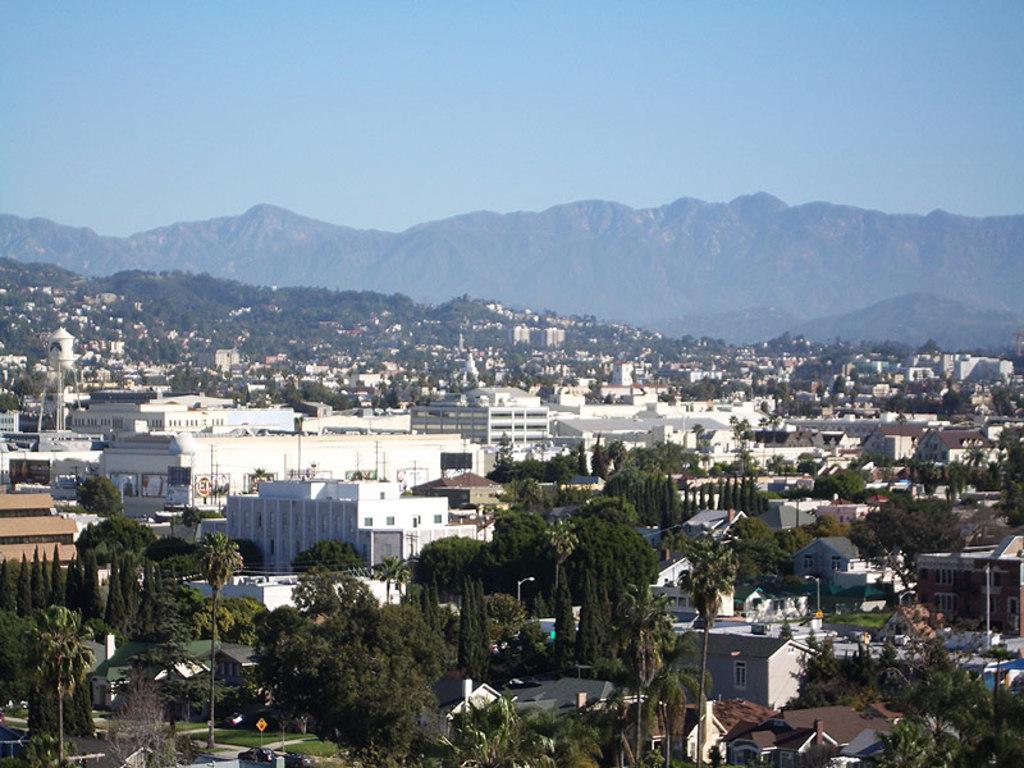Please provide a concise description of this image. In this image there is the sky truncated towards the top of the image, there are mountains truncated, there are trees, there are buildings, there are buildings truncated towards the right of the image, there are buildings truncated towards the left of the image, there is a board, there is a pole, there are trees truncated towards the bottom of the image, there are trees truncated towards the left of the image. 